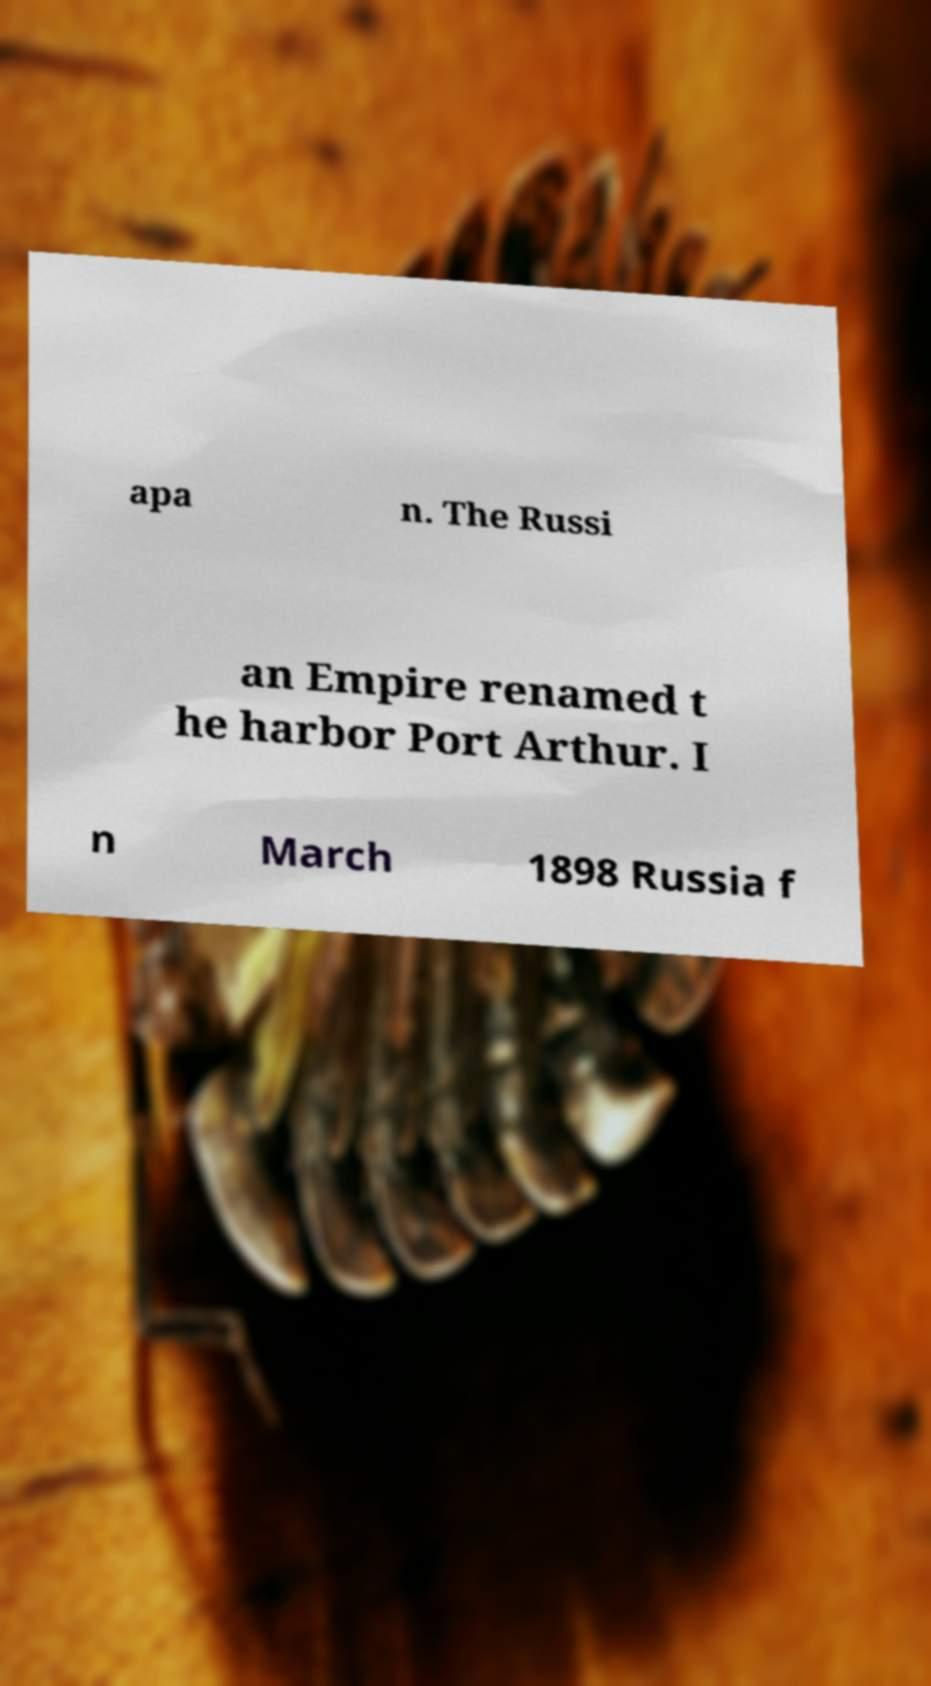I need the written content from this picture converted into text. Can you do that? apa n. The Russi an Empire renamed t he harbor Port Arthur. I n March 1898 Russia f 